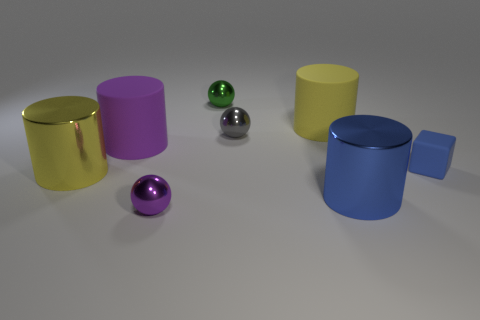There is a purple cylinder; does it have the same size as the metallic sphere in front of the large yellow shiny object?
Your response must be concise. No. How big is the metallic cylinder that is on the right side of the purple thing that is in front of the big blue metal cylinder?
Give a very brief answer. Large. The other matte object that is the same shape as the big yellow rubber thing is what color?
Your response must be concise. Purple. Do the cube and the yellow rubber thing have the same size?
Provide a short and direct response. No. Are there an equal number of large yellow shiny cylinders that are right of the small purple sphere and small blue matte cubes?
Your answer should be very brief. No. There is a blue cube on the right side of the tiny green object; are there any tiny blue matte things that are behind it?
Offer a very short reply. No. What is the size of the rubber object to the right of the big metallic cylinder that is in front of the large yellow cylinder in front of the big purple rubber cylinder?
Your answer should be compact. Small. What material is the yellow object in front of the big matte cylinder that is behind the small gray shiny object?
Your answer should be compact. Metal. Are there any large purple things that have the same shape as the blue metallic thing?
Give a very brief answer. Yes. What is the shape of the small blue thing?
Your answer should be very brief. Cube. 